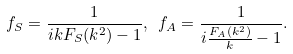<formula> <loc_0><loc_0><loc_500><loc_500>f _ { S } = \frac { 1 } { i k F _ { S } ( k ^ { 2 } ) - 1 } , \ f _ { A } = \frac { 1 } { i \frac { F _ { A } ( k ^ { 2 } ) } { k } - 1 } .</formula> 